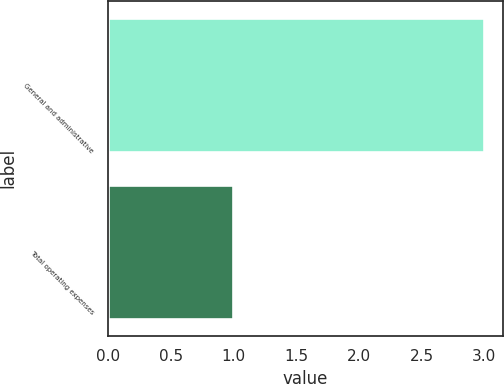Convert chart to OTSL. <chart><loc_0><loc_0><loc_500><loc_500><bar_chart><fcel>General and administrative<fcel>Total operating expenses<nl><fcel>3<fcel>1<nl></chart> 